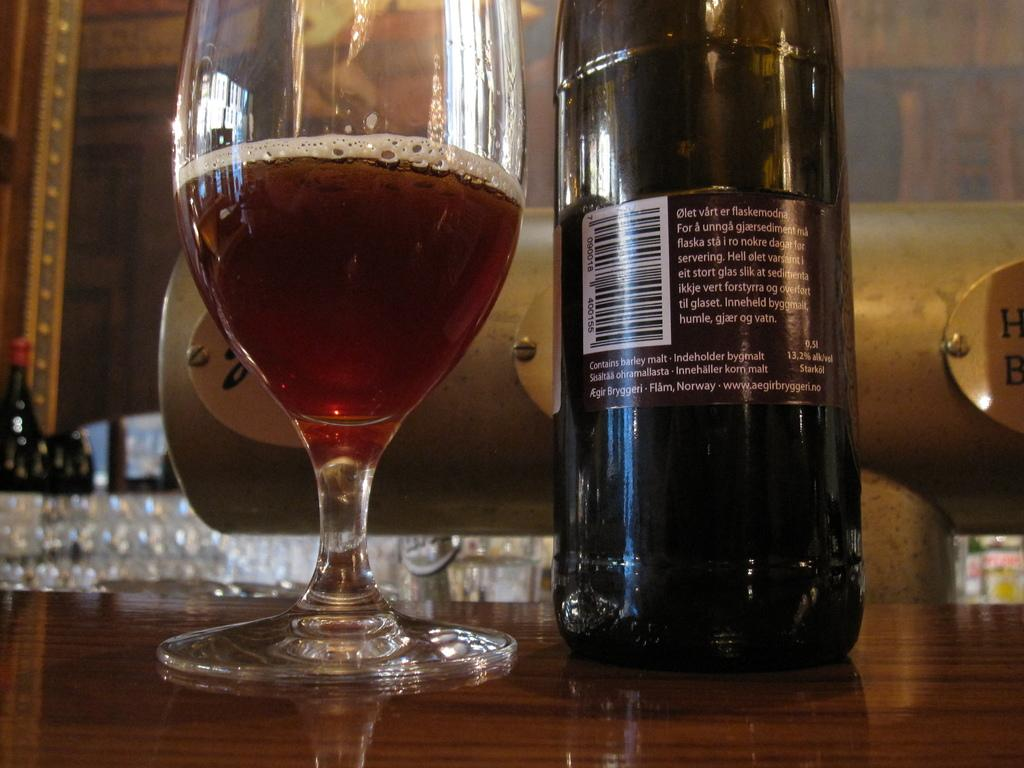<image>
Render a clear and concise summary of the photo. Aegirbryggeri.no website on a bottle of Malt Wine. 